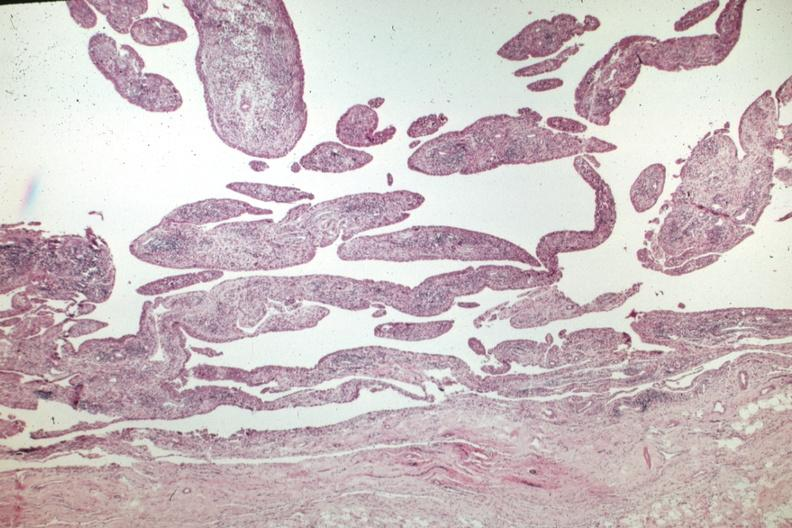what is present?
Answer the question using a single word or phrase. Joints 